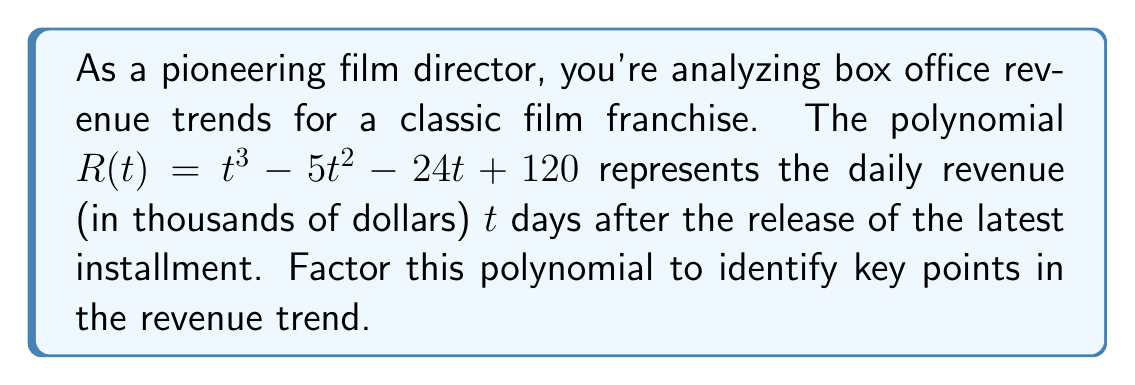Show me your answer to this math problem. Let's approach this step-by-step:

1) First, we'll check if there are any rational roots using the rational root theorem. The possible rational roots are the factors of the constant term: ±1, ±2, ±3, ±4, ±5, ±6, ±8, ±10, ±12, ±15, ±20, ±24, ±30, ±40, ±60, ±120.

2) Testing these values, we find that 8 is a root. So $(t-8)$ is a factor.

3) We can use polynomial long division to divide $R(t)$ by $(t-8)$:

   $$\frac{t^3 - 5t^2 - 24t + 120}{t - 8} = t^2 + 3t - 15$$

4) Now we have: $R(t) = (t-8)(t^2 + 3t - 15)$

5) We can factor the quadratic term $t^2 + 3t - 15$ further:
   
   $$t^2 + 3t - 15 = (t+5)(t-2)$$

6) Therefore, the fully factored polynomial is:

   $$R(t) = (t-8)(t+5)(t-2)$$

This factorization reveals that the revenue function has roots at $t=8$, $t=-5$, and $t=2$, representing key points in the revenue trend.
Answer: $(t-8)(t+5)(t-2)$ 